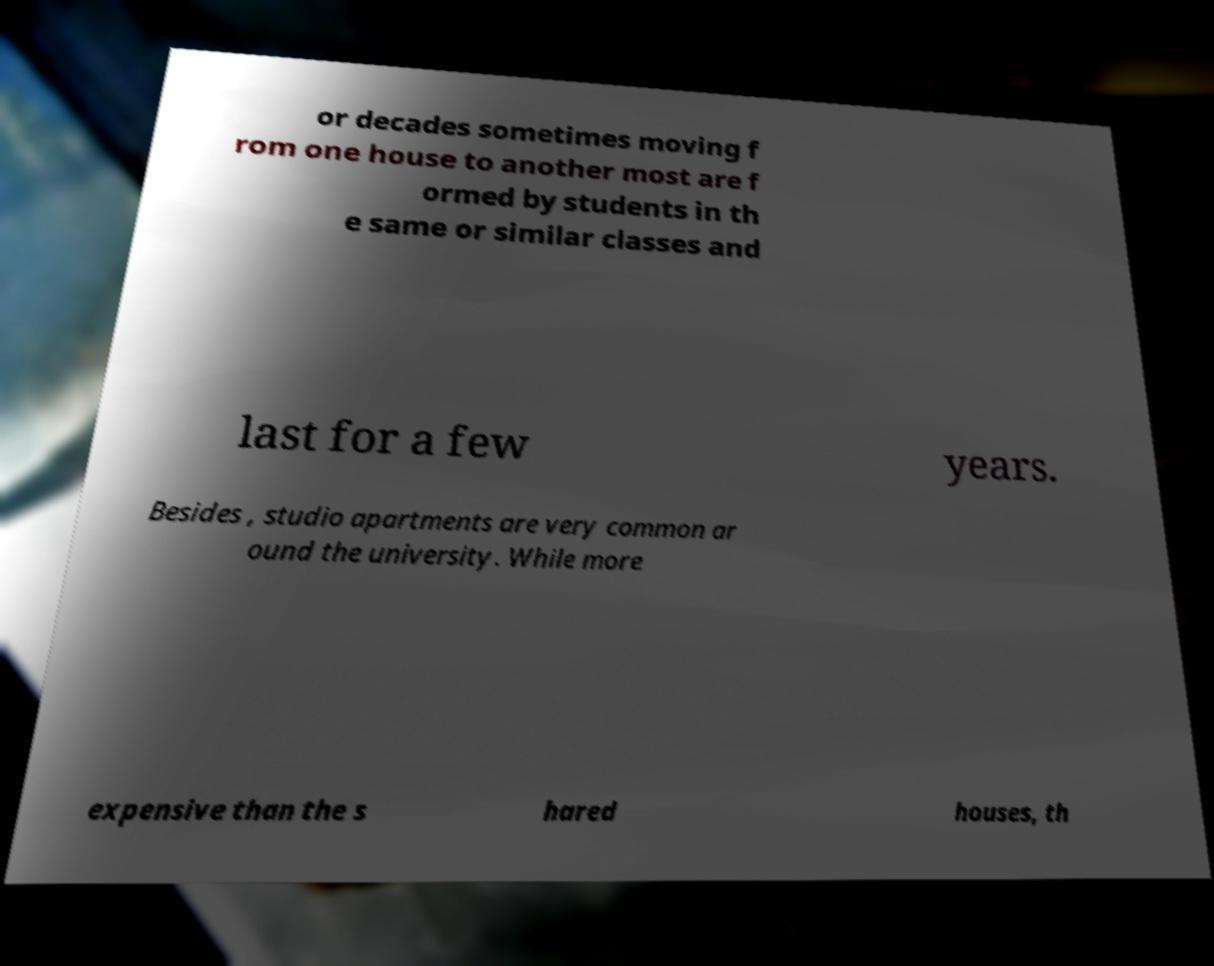What messages or text are displayed in this image? I need them in a readable, typed format. or decades sometimes moving f rom one house to another most are f ormed by students in th e same or similar classes and last for a few years. Besides , studio apartments are very common ar ound the university. While more expensive than the s hared houses, th 